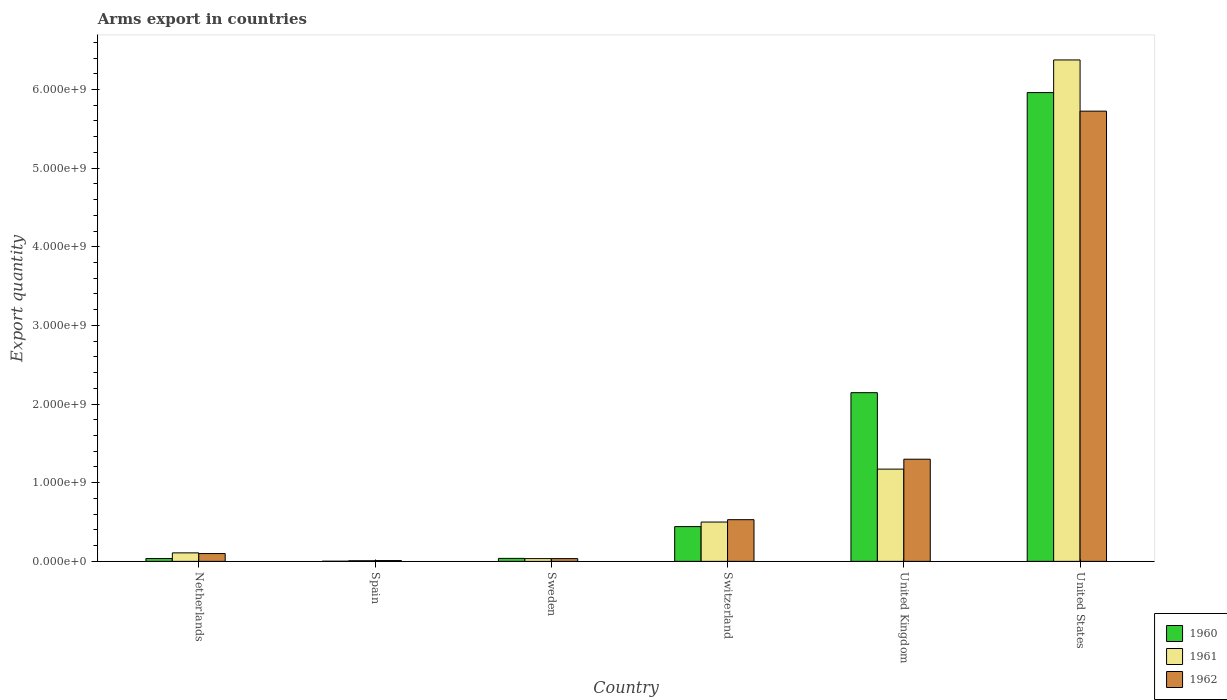How many different coloured bars are there?
Ensure brevity in your answer.  3. How many groups of bars are there?
Keep it short and to the point. 6. How many bars are there on the 1st tick from the right?
Make the answer very short. 3. What is the label of the 1st group of bars from the left?
Offer a very short reply. Netherlands. In how many cases, is the number of bars for a given country not equal to the number of legend labels?
Offer a very short reply. 0. What is the total arms export in 1961 in Switzerland?
Offer a terse response. 5.00e+08. Across all countries, what is the maximum total arms export in 1962?
Provide a succinct answer. 5.72e+09. Across all countries, what is the minimum total arms export in 1961?
Make the answer very short. 8.00e+06. In which country was the total arms export in 1961 minimum?
Offer a very short reply. Spain. What is the total total arms export in 1962 in the graph?
Offer a terse response. 7.70e+09. What is the difference between the total arms export in 1962 in Netherlands and that in United States?
Ensure brevity in your answer.  -5.63e+09. What is the difference between the total arms export in 1960 in Switzerland and the total arms export in 1961 in United Kingdom?
Keep it short and to the point. -7.31e+08. What is the average total arms export in 1961 per country?
Provide a succinct answer. 1.37e+09. What is the difference between the total arms export of/in 1960 and total arms export of/in 1961 in United States?
Offer a terse response. -4.15e+08. In how many countries, is the total arms export in 1960 greater than 1600000000?
Your answer should be compact. 2. What is the ratio of the total arms export in 1962 in Netherlands to that in Sweden?
Ensure brevity in your answer.  2.83. Is the total arms export in 1962 in Netherlands less than that in Sweden?
Your answer should be compact. No. Is the difference between the total arms export in 1960 in Sweden and Switzerland greater than the difference between the total arms export in 1961 in Sweden and Switzerland?
Your response must be concise. Yes. What is the difference between the highest and the second highest total arms export in 1962?
Give a very brief answer. 5.20e+09. What is the difference between the highest and the lowest total arms export in 1960?
Offer a very short reply. 5.96e+09. How many countries are there in the graph?
Make the answer very short. 6. What is the difference between two consecutive major ticks on the Y-axis?
Your response must be concise. 1.00e+09. Where does the legend appear in the graph?
Provide a succinct answer. Bottom right. How are the legend labels stacked?
Provide a short and direct response. Vertical. What is the title of the graph?
Your response must be concise. Arms export in countries. Does "1981" appear as one of the legend labels in the graph?
Your response must be concise. No. What is the label or title of the X-axis?
Give a very brief answer. Country. What is the label or title of the Y-axis?
Provide a short and direct response. Export quantity. What is the Export quantity of 1960 in Netherlands?
Provide a short and direct response. 3.60e+07. What is the Export quantity in 1961 in Netherlands?
Ensure brevity in your answer.  1.08e+08. What is the Export quantity of 1962 in Netherlands?
Provide a short and direct response. 9.90e+07. What is the Export quantity in 1960 in Spain?
Your answer should be very brief. 2.00e+06. What is the Export quantity of 1961 in Spain?
Your answer should be very brief. 8.00e+06. What is the Export quantity in 1962 in Spain?
Your response must be concise. 1.00e+07. What is the Export quantity of 1960 in Sweden?
Your answer should be compact. 3.80e+07. What is the Export quantity in 1961 in Sweden?
Keep it short and to the point. 3.50e+07. What is the Export quantity of 1962 in Sweden?
Your answer should be compact. 3.50e+07. What is the Export quantity of 1960 in Switzerland?
Your answer should be compact. 4.42e+08. What is the Export quantity of 1961 in Switzerland?
Provide a succinct answer. 5.00e+08. What is the Export quantity in 1962 in Switzerland?
Offer a very short reply. 5.30e+08. What is the Export quantity of 1960 in United Kingdom?
Provide a succinct answer. 2.14e+09. What is the Export quantity of 1961 in United Kingdom?
Your answer should be very brief. 1.17e+09. What is the Export quantity of 1962 in United Kingdom?
Provide a short and direct response. 1.30e+09. What is the Export quantity of 1960 in United States?
Give a very brief answer. 5.96e+09. What is the Export quantity of 1961 in United States?
Provide a short and direct response. 6.38e+09. What is the Export quantity of 1962 in United States?
Offer a terse response. 5.72e+09. Across all countries, what is the maximum Export quantity in 1960?
Offer a very short reply. 5.96e+09. Across all countries, what is the maximum Export quantity of 1961?
Keep it short and to the point. 6.38e+09. Across all countries, what is the maximum Export quantity in 1962?
Your answer should be very brief. 5.72e+09. Across all countries, what is the minimum Export quantity of 1961?
Offer a very short reply. 8.00e+06. What is the total Export quantity in 1960 in the graph?
Provide a short and direct response. 8.62e+09. What is the total Export quantity of 1961 in the graph?
Offer a very short reply. 8.20e+09. What is the total Export quantity in 1962 in the graph?
Make the answer very short. 7.70e+09. What is the difference between the Export quantity of 1960 in Netherlands and that in Spain?
Make the answer very short. 3.40e+07. What is the difference between the Export quantity in 1961 in Netherlands and that in Spain?
Provide a short and direct response. 1.00e+08. What is the difference between the Export quantity in 1962 in Netherlands and that in Spain?
Your answer should be compact. 8.90e+07. What is the difference between the Export quantity in 1960 in Netherlands and that in Sweden?
Your response must be concise. -2.00e+06. What is the difference between the Export quantity in 1961 in Netherlands and that in Sweden?
Keep it short and to the point. 7.30e+07. What is the difference between the Export quantity of 1962 in Netherlands and that in Sweden?
Give a very brief answer. 6.40e+07. What is the difference between the Export quantity in 1960 in Netherlands and that in Switzerland?
Keep it short and to the point. -4.06e+08. What is the difference between the Export quantity of 1961 in Netherlands and that in Switzerland?
Provide a short and direct response. -3.92e+08. What is the difference between the Export quantity in 1962 in Netherlands and that in Switzerland?
Give a very brief answer. -4.31e+08. What is the difference between the Export quantity in 1960 in Netherlands and that in United Kingdom?
Your answer should be very brief. -2.11e+09. What is the difference between the Export quantity in 1961 in Netherlands and that in United Kingdom?
Make the answer very short. -1.06e+09. What is the difference between the Export quantity in 1962 in Netherlands and that in United Kingdom?
Offer a terse response. -1.20e+09. What is the difference between the Export quantity of 1960 in Netherlands and that in United States?
Offer a very short reply. -5.92e+09. What is the difference between the Export quantity of 1961 in Netherlands and that in United States?
Keep it short and to the point. -6.27e+09. What is the difference between the Export quantity in 1962 in Netherlands and that in United States?
Ensure brevity in your answer.  -5.63e+09. What is the difference between the Export quantity in 1960 in Spain and that in Sweden?
Offer a terse response. -3.60e+07. What is the difference between the Export quantity in 1961 in Spain and that in Sweden?
Provide a succinct answer. -2.70e+07. What is the difference between the Export quantity in 1962 in Spain and that in Sweden?
Offer a terse response. -2.50e+07. What is the difference between the Export quantity of 1960 in Spain and that in Switzerland?
Your answer should be compact. -4.40e+08. What is the difference between the Export quantity in 1961 in Spain and that in Switzerland?
Keep it short and to the point. -4.92e+08. What is the difference between the Export quantity of 1962 in Spain and that in Switzerland?
Provide a succinct answer. -5.20e+08. What is the difference between the Export quantity of 1960 in Spain and that in United Kingdom?
Your response must be concise. -2.14e+09. What is the difference between the Export quantity in 1961 in Spain and that in United Kingdom?
Offer a terse response. -1.16e+09. What is the difference between the Export quantity of 1962 in Spain and that in United Kingdom?
Provide a short and direct response. -1.29e+09. What is the difference between the Export quantity of 1960 in Spain and that in United States?
Your response must be concise. -5.96e+09. What is the difference between the Export quantity of 1961 in Spain and that in United States?
Your response must be concise. -6.37e+09. What is the difference between the Export quantity of 1962 in Spain and that in United States?
Provide a succinct answer. -5.72e+09. What is the difference between the Export quantity in 1960 in Sweden and that in Switzerland?
Keep it short and to the point. -4.04e+08. What is the difference between the Export quantity of 1961 in Sweden and that in Switzerland?
Ensure brevity in your answer.  -4.65e+08. What is the difference between the Export quantity in 1962 in Sweden and that in Switzerland?
Give a very brief answer. -4.95e+08. What is the difference between the Export quantity in 1960 in Sweden and that in United Kingdom?
Make the answer very short. -2.11e+09. What is the difference between the Export quantity in 1961 in Sweden and that in United Kingdom?
Provide a succinct answer. -1.14e+09. What is the difference between the Export quantity in 1962 in Sweden and that in United Kingdom?
Your response must be concise. -1.26e+09. What is the difference between the Export quantity of 1960 in Sweden and that in United States?
Make the answer very short. -5.92e+09. What is the difference between the Export quantity of 1961 in Sweden and that in United States?
Ensure brevity in your answer.  -6.34e+09. What is the difference between the Export quantity of 1962 in Sweden and that in United States?
Your response must be concise. -5.69e+09. What is the difference between the Export quantity in 1960 in Switzerland and that in United Kingdom?
Your answer should be compact. -1.70e+09. What is the difference between the Export quantity of 1961 in Switzerland and that in United Kingdom?
Keep it short and to the point. -6.73e+08. What is the difference between the Export quantity in 1962 in Switzerland and that in United Kingdom?
Provide a short and direct response. -7.69e+08. What is the difference between the Export quantity in 1960 in Switzerland and that in United States?
Your response must be concise. -5.52e+09. What is the difference between the Export quantity of 1961 in Switzerland and that in United States?
Ensure brevity in your answer.  -5.88e+09. What is the difference between the Export quantity of 1962 in Switzerland and that in United States?
Your answer should be compact. -5.20e+09. What is the difference between the Export quantity in 1960 in United Kingdom and that in United States?
Ensure brevity in your answer.  -3.82e+09. What is the difference between the Export quantity of 1961 in United Kingdom and that in United States?
Give a very brief answer. -5.20e+09. What is the difference between the Export quantity in 1962 in United Kingdom and that in United States?
Make the answer very short. -4.43e+09. What is the difference between the Export quantity in 1960 in Netherlands and the Export quantity in 1961 in Spain?
Provide a short and direct response. 2.80e+07. What is the difference between the Export quantity of 1960 in Netherlands and the Export quantity of 1962 in Spain?
Ensure brevity in your answer.  2.60e+07. What is the difference between the Export quantity of 1961 in Netherlands and the Export quantity of 1962 in Spain?
Keep it short and to the point. 9.80e+07. What is the difference between the Export quantity in 1960 in Netherlands and the Export quantity in 1961 in Sweden?
Make the answer very short. 1.00e+06. What is the difference between the Export quantity in 1960 in Netherlands and the Export quantity in 1962 in Sweden?
Make the answer very short. 1.00e+06. What is the difference between the Export quantity of 1961 in Netherlands and the Export quantity of 1962 in Sweden?
Your response must be concise. 7.30e+07. What is the difference between the Export quantity of 1960 in Netherlands and the Export quantity of 1961 in Switzerland?
Your answer should be compact. -4.64e+08. What is the difference between the Export quantity of 1960 in Netherlands and the Export quantity of 1962 in Switzerland?
Keep it short and to the point. -4.94e+08. What is the difference between the Export quantity of 1961 in Netherlands and the Export quantity of 1962 in Switzerland?
Your answer should be very brief. -4.22e+08. What is the difference between the Export quantity in 1960 in Netherlands and the Export quantity in 1961 in United Kingdom?
Keep it short and to the point. -1.14e+09. What is the difference between the Export quantity in 1960 in Netherlands and the Export quantity in 1962 in United Kingdom?
Your answer should be very brief. -1.26e+09. What is the difference between the Export quantity in 1961 in Netherlands and the Export quantity in 1962 in United Kingdom?
Make the answer very short. -1.19e+09. What is the difference between the Export quantity of 1960 in Netherlands and the Export quantity of 1961 in United States?
Ensure brevity in your answer.  -6.34e+09. What is the difference between the Export quantity in 1960 in Netherlands and the Export quantity in 1962 in United States?
Provide a succinct answer. -5.69e+09. What is the difference between the Export quantity of 1961 in Netherlands and the Export quantity of 1962 in United States?
Provide a short and direct response. -5.62e+09. What is the difference between the Export quantity of 1960 in Spain and the Export quantity of 1961 in Sweden?
Offer a terse response. -3.30e+07. What is the difference between the Export quantity in 1960 in Spain and the Export quantity in 1962 in Sweden?
Keep it short and to the point. -3.30e+07. What is the difference between the Export quantity of 1961 in Spain and the Export quantity of 1962 in Sweden?
Give a very brief answer. -2.70e+07. What is the difference between the Export quantity in 1960 in Spain and the Export quantity in 1961 in Switzerland?
Provide a short and direct response. -4.98e+08. What is the difference between the Export quantity in 1960 in Spain and the Export quantity in 1962 in Switzerland?
Your answer should be compact. -5.28e+08. What is the difference between the Export quantity in 1961 in Spain and the Export quantity in 1962 in Switzerland?
Give a very brief answer. -5.22e+08. What is the difference between the Export quantity of 1960 in Spain and the Export quantity of 1961 in United Kingdom?
Provide a short and direct response. -1.17e+09. What is the difference between the Export quantity in 1960 in Spain and the Export quantity in 1962 in United Kingdom?
Your answer should be very brief. -1.30e+09. What is the difference between the Export quantity in 1961 in Spain and the Export quantity in 1962 in United Kingdom?
Offer a terse response. -1.29e+09. What is the difference between the Export quantity in 1960 in Spain and the Export quantity in 1961 in United States?
Offer a terse response. -6.37e+09. What is the difference between the Export quantity in 1960 in Spain and the Export quantity in 1962 in United States?
Keep it short and to the point. -5.72e+09. What is the difference between the Export quantity in 1961 in Spain and the Export quantity in 1962 in United States?
Ensure brevity in your answer.  -5.72e+09. What is the difference between the Export quantity in 1960 in Sweden and the Export quantity in 1961 in Switzerland?
Your answer should be compact. -4.62e+08. What is the difference between the Export quantity in 1960 in Sweden and the Export quantity in 1962 in Switzerland?
Make the answer very short. -4.92e+08. What is the difference between the Export quantity in 1961 in Sweden and the Export quantity in 1962 in Switzerland?
Your answer should be very brief. -4.95e+08. What is the difference between the Export quantity in 1960 in Sweden and the Export quantity in 1961 in United Kingdom?
Your answer should be compact. -1.14e+09. What is the difference between the Export quantity of 1960 in Sweden and the Export quantity of 1962 in United Kingdom?
Ensure brevity in your answer.  -1.26e+09. What is the difference between the Export quantity of 1961 in Sweden and the Export quantity of 1962 in United Kingdom?
Keep it short and to the point. -1.26e+09. What is the difference between the Export quantity of 1960 in Sweden and the Export quantity of 1961 in United States?
Your response must be concise. -6.34e+09. What is the difference between the Export quantity in 1960 in Sweden and the Export quantity in 1962 in United States?
Make the answer very short. -5.69e+09. What is the difference between the Export quantity in 1961 in Sweden and the Export quantity in 1962 in United States?
Give a very brief answer. -5.69e+09. What is the difference between the Export quantity of 1960 in Switzerland and the Export quantity of 1961 in United Kingdom?
Your response must be concise. -7.31e+08. What is the difference between the Export quantity in 1960 in Switzerland and the Export quantity in 1962 in United Kingdom?
Your answer should be very brief. -8.57e+08. What is the difference between the Export quantity of 1961 in Switzerland and the Export quantity of 1962 in United Kingdom?
Give a very brief answer. -7.99e+08. What is the difference between the Export quantity in 1960 in Switzerland and the Export quantity in 1961 in United States?
Offer a terse response. -5.93e+09. What is the difference between the Export quantity of 1960 in Switzerland and the Export quantity of 1962 in United States?
Offer a very short reply. -5.28e+09. What is the difference between the Export quantity in 1961 in Switzerland and the Export quantity in 1962 in United States?
Provide a succinct answer. -5.22e+09. What is the difference between the Export quantity of 1960 in United Kingdom and the Export quantity of 1961 in United States?
Provide a succinct answer. -4.23e+09. What is the difference between the Export quantity of 1960 in United Kingdom and the Export quantity of 1962 in United States?
Provide a short and direct response. -3.58e+09. What is the difference between the Export quantity of 1961 in United Kingdom and the Export quantity of 1962 in United States?
Make the answer very short. -4.55e+09. What is the average Export quantity in 1960 per country?
Offer a terse response. 1.44e+09. What is the average Export quantity in 1961 per country?
Offer a very short reply. 1.37e+09. What is the average Export quantity in 1962 per country?
Your response must be concise. 1.28e+09. What is the difference between the Export quantity in 1960 and Export quantity in 1961 in Netherlands?
Offer a terse response. -7.20e+07. What is the difference between the Export quantity in 1960 and Export quantity in 1962 in Netherlands?
Your answer should be very brief. -6.30e+07. What is the difference between the Export quantity of 1961 and Export quantity of 1962 in Netherlands?
Keep it short and to the point. 9.00e+06. What is the difference between the Export quantity of 1960 and Export quantity of 1961 in Spain?
Your answer should be very brief. -6.00e+06. What is the difference between the Export quantity in 1960 and Export quantity in 1962 in Spain?
Make the answer very short. -8.00e+06. What is the difference between the Export quantity in 1961 and Export quantity in 1962 in Spain?
Make the answer very short. -2.00e+06. What is the difference between the Export quantity of 1960 and Export quantity of 1961 in Sweden?
Keep it short and to the point. 3.00e+06. What is the difference between the Export quantity of 1960 and Export quantity of 1962 in Sweden?
Offer a very short reply. 3.00e+06. What is the difference between the Export quantity in 1960 and Export quantity in 1961 in Switzerland?
Offer a terse response. -5.80e+07. What is the difference between the Export quantity of 1960 and Export quantity of 1962 in Switzerland?
Your response must be concise. -8.80e+07. What is the difference between the Export quantity of 1961 and Export quantity of 1962 in Switzerland?
Keep it short and to the point. -3.00e+07. What is the difference between the Export quantity of 1960 and Export quantity of 1961 in United Kingdom?
Provide a short and direct response. 9.72e+08. What is the difference between the Export quantity in 1960 and Export quantity in 1962 in United Kingdom?
Offer a very short reply. 8.46e+08. What is the difference between the Export quantity in 1961 and Export quantity in 1962 in United Kingdom?
Give a very brief answer. -1.26e+08. What is the difference between the Export quantity of 1960 and Export quantity of 1961 in United States?
Give a very brief answer. -4.15e+08. What is the difference between the Export quantity in 1960 and Export quantity in 1962 in United States?
Keep it short and to the point. 2.36e+08. What is the difference between the Export quantity in 1961 and Export quantity in 1962 in United States?
Your answer should be very brief. 6.51e+08. What is the ratio of the Export quantity of 1961 in Netherlands to that in Sweden?
Offer a very short reply. 3.09. What is the ratio of the Export quantity of 1962 in Netherlands to that in Sweden?
Your response must be concise. 2.83. What is the ratio of the Export quantity in 1960 in Netherlands to that in Switzerland?
Ensure brevity in your answer.  0.08. What is the ratio of the Export quantity of 1961 in Netherlands to that in Switzerland?
Offer a very short reply. 0.22. What is the ratio of the Export quantity in 1962 in Netherlands to that in Switzerland?
Provide a short and direct response. 0.19. What is the ratio of the Export quantity of 1960 in Netherlands to that in United Kingdom?
Offer a very short reply. 0.02. What is the ratio of the Export quantity in 1961 in Netherlands to that in United Kingdom?
Your response must be concise. 0.09. What is the ratio of the Export quantity in 1962 in Netherlands to that in United Kingdom?
Offer a terse response. 0.08. What is the ratio of the Export quantity in 1960 in Netherlands to that in United States?
Provide a short and direct response. 0.01. What is the ratio of the Export quantity of 1961 in Netherlands to that in United States?
Give a very brief answer. 0.02. What is the ratio of the Export quantity in 1962 in Netherlands to that in United States?
Your answer should be compact. 0.02. What is the ratio of the Export quantity in 1960 in Spain to that in Sweden?
Keep it short and to the point. 0.05. What is the ratio of the Export quantity in 1961 in Spain to that in Sweden?
Your answer should be very brief. 0.23. What is the ratio of the Export quantity in 1962 in Spain to that in Sweden?
Offer a terse response. 0.29. What is the ratio of the Export quantity of 1960 in Spain to that in Switzerland?
Provide a succinct answer. 0. What is the ratio of the Export quantity of 1961 in Spain to that in Switzerland?
Provide a succinct answer. 0.02. What is the ratio of the Export quantity of 1962 in Spain to that in Switzerland?
Give a very brief answer. 0.02. What is the ratio of the Export quantity of 1960 in Spain to that in United Kingdom?
Ensure brevity in your answer.  0. What is the ratio of the Export quantity in 1961 in Spain to that in United Kingdom?
Keep it short and to the point. 0.01. What is the ratio of the Export quantity of 1962 in Spain to that in United Kingdom?
Give a very brief answer. 0.01. What is the ratio of the Export quantity in 1960 in Spain to that in United States?
Give a very brief answer. 0. What is the ratio of the Export quantity of 1961 in Spain to that in United States?
Make the answer very short. 0. What is the ratio of the Export quantity in 1962 in Spain to that in United States?
Make the answer very short. 0. What is the ratio of the Export quantity in 1960 in Sweden to that in Switzerland?
Provide a short and direct response. 0.09. What is the ratio of the Export quantity in 1961 in Sweden to that in Switzerland?
Ensure brevity in your answer.  0.07. What is the ratio of the Export quantity of 1962 in Sweden to that in Switzerland?
Make the answer very short. 0.07. What is the ratio of the Export quantity in 1960 in Sweden to that in United Kingdom?
Your answer should be compact. 0.02. What is the ratio of the Export quantity of 1961 in Sweden to that in United Kingdom?
Make the answer very short. 0.03. What is the ratio of the Export quantity in 1962 in Sweden to that in United Kingdom?
Offer a terse response. 0.03. What is the ratio of the Export quantity in 1960 in Sweden to that in United States?
Offer a very short reply. 0.01. What is the ratio of the Export quantity in 1961 in Sweden to that in United States?
Your answer should be very brief. 0.01. What is the ratio of the Export quantity in 1962 in Sweden to that in United States?
Your answer should be compact. 0.01. What is the ratio of the Export quantity in 1960 in Switzerland to that in United Kingdom?
Provide a short and direct response. 0.21. What is the ratio of the Export quantity in 1961 in Switzerland to that in United Kingdom?
Offer a very short reply. 0.43. What is the ratio of the Export quantity of 1962 in Switzerland to that in United Kingdom?
Ensure brevity in your answer.  0.41. What is the ratio of the Export quantity in 1960 in Switzerland to that in United States?
Ensure brevity in your answer.  0.07. What is the ratio of the Export quantity in 1961 in Switzerland to that in United States?
Provide a succinct answer. 0.08. What is the ratio of the Export quantity of 1962 in Switzerland to that in United States?
Your answer should be compact. 0.09. What is the ratio of the Export quantity of 1960 in United Kingdom to that in United States?
Ensure brevity in your answer.  0.36. What is the ratio of the Export quantity of 1961 in United Kingdom to that in United States?
Your response must be concise. 0.18. What is the ratio of the Export quantity in 1962 in United Kingdom to that in United States?
Your answer should be very brief. 0.23. What is the difference between the highest and the second highest Export quantity of 1960?
Provide a succinct answer. 3.82e+09. What is the difference between the highest and the second highest Export quantity in 1961?
Your response must be concise. 5.20e+09. What is the difference between the highest and the second highest Export quantity in 1962?
Your answer should be compact. 4.43e+09. What is the difference between the highest and the lowest Export quantity of 1960?
Give a very brief answer. 5.96e+09. What is the difference between the highest and the lowest Export quantity in 1961?
Offer a terse response. 6.37e+09. What is the difference between the highest and the lowest Export quantity of 1962?
Your answer should be compact. 5.72e+09. 